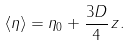Convert formula to latex. <formula><loc_0><loc_0><loc_500><loc_500>\langle \eta \rangle = \eta _ { 0 } + \frac { 3 D } { 4 } \, z .</formula> 